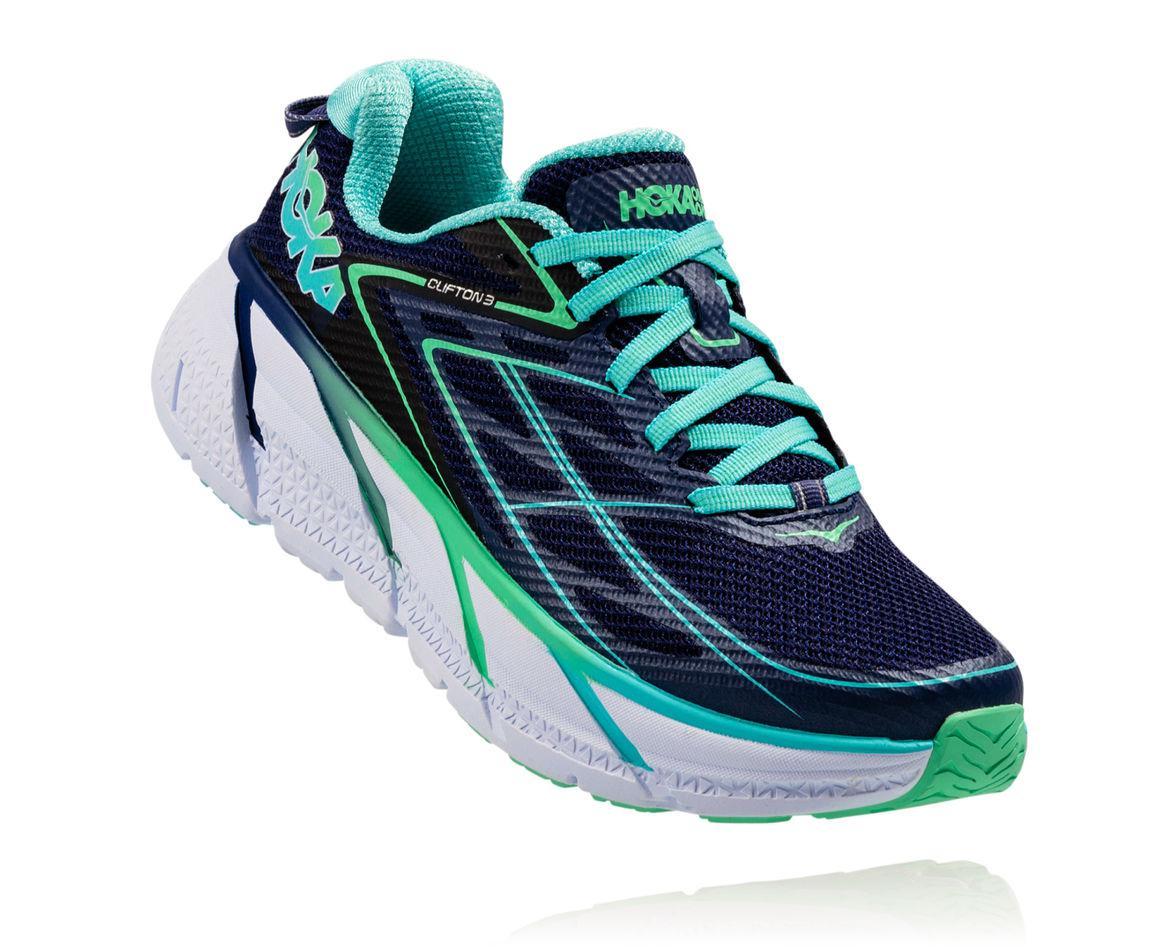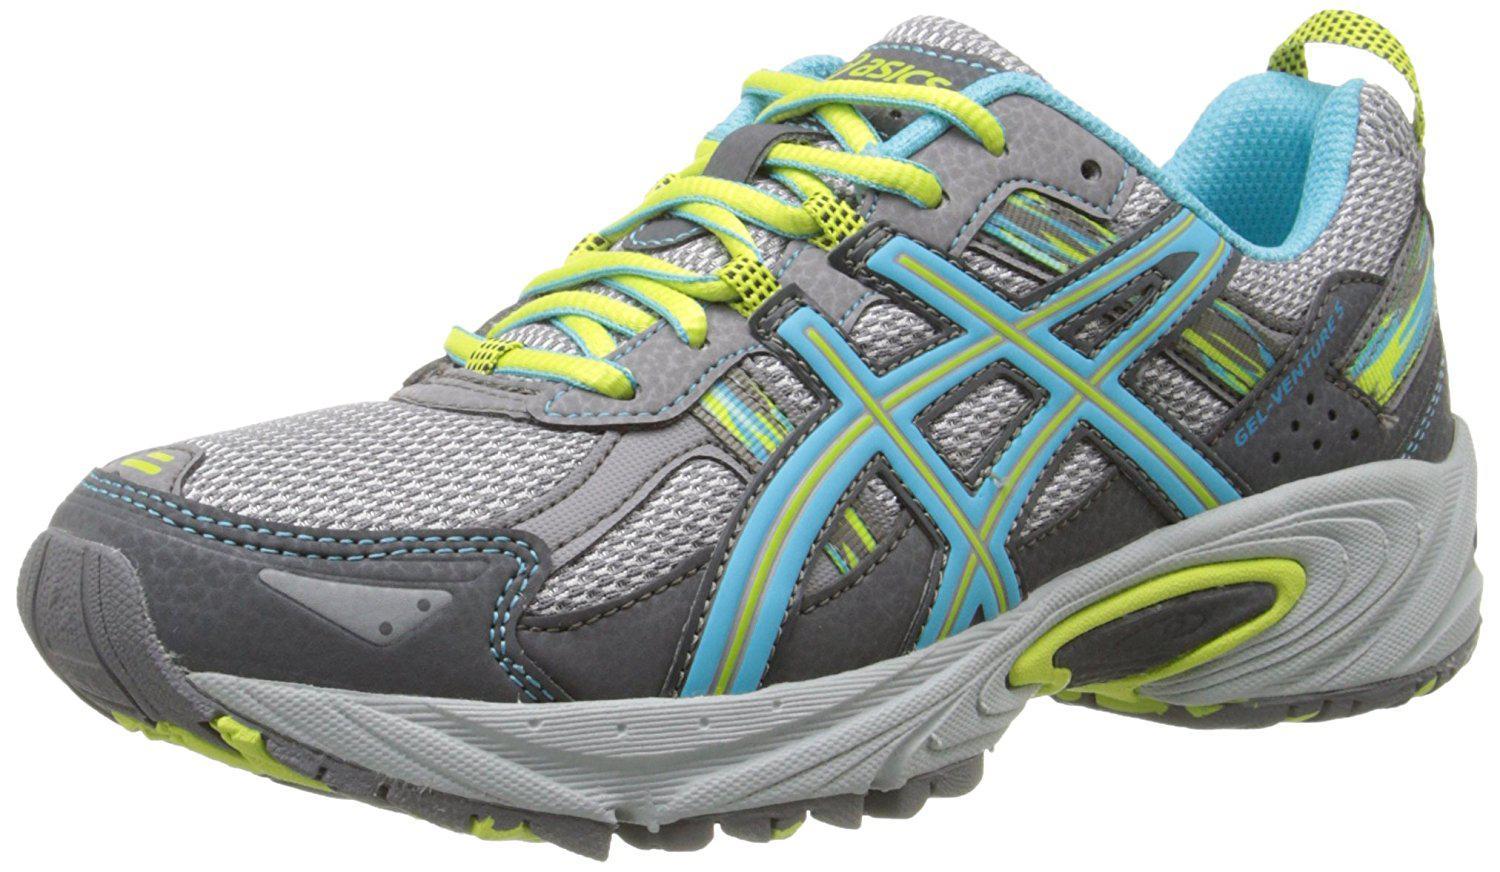The first image is the image on the left, the second image is the image on the right. Examine the images to the left and right. Is the description "At least one sneaker incorporates purple in its design." accurate? Answer yes or no. No. The first image is the image on the left, the second image is the image on the right. Analyze the images presented: Is the assertion "Exactly three shoes are shown, a pair in one image with one turned over with visible sole treads, while a single shoe in the other image is a different color scheme and design." valid? Answer yes or no. No. 